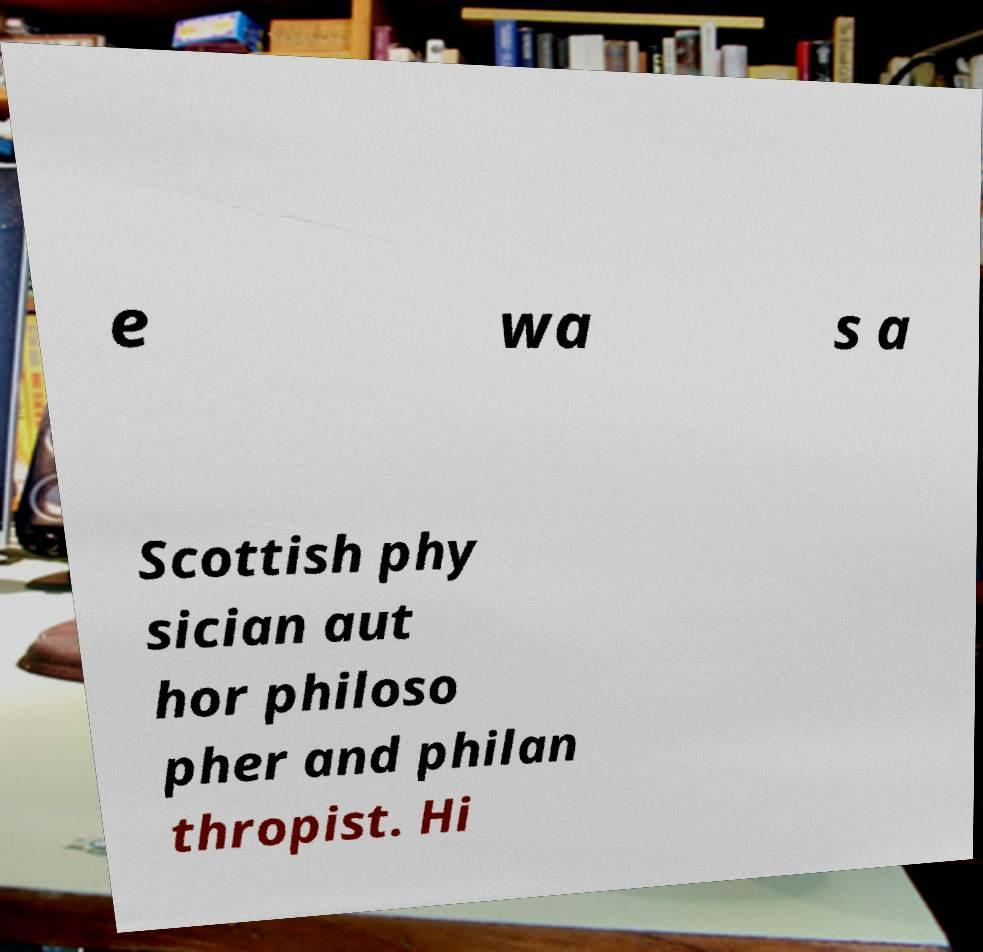Please read and relay the text visible in this image. What does it say? e wa s a Scottish phy sician aut hor philoso pher and philan thropist. Hi 